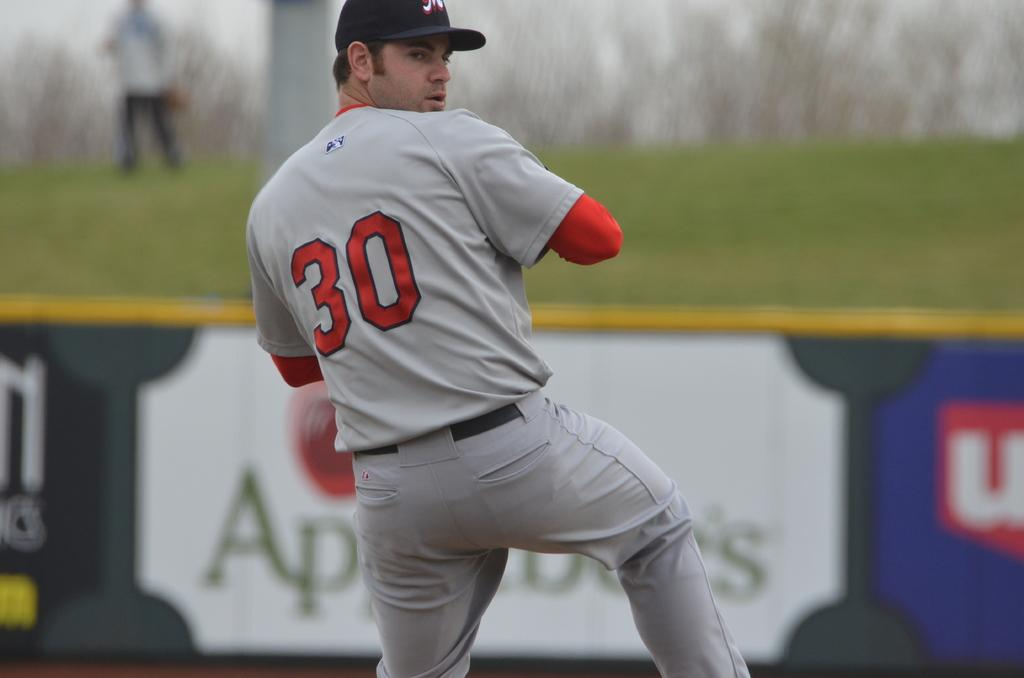<image>
Summarize the visual content of the image. the number 30 baseball pitcher standing on the mound ready to throw the ball 